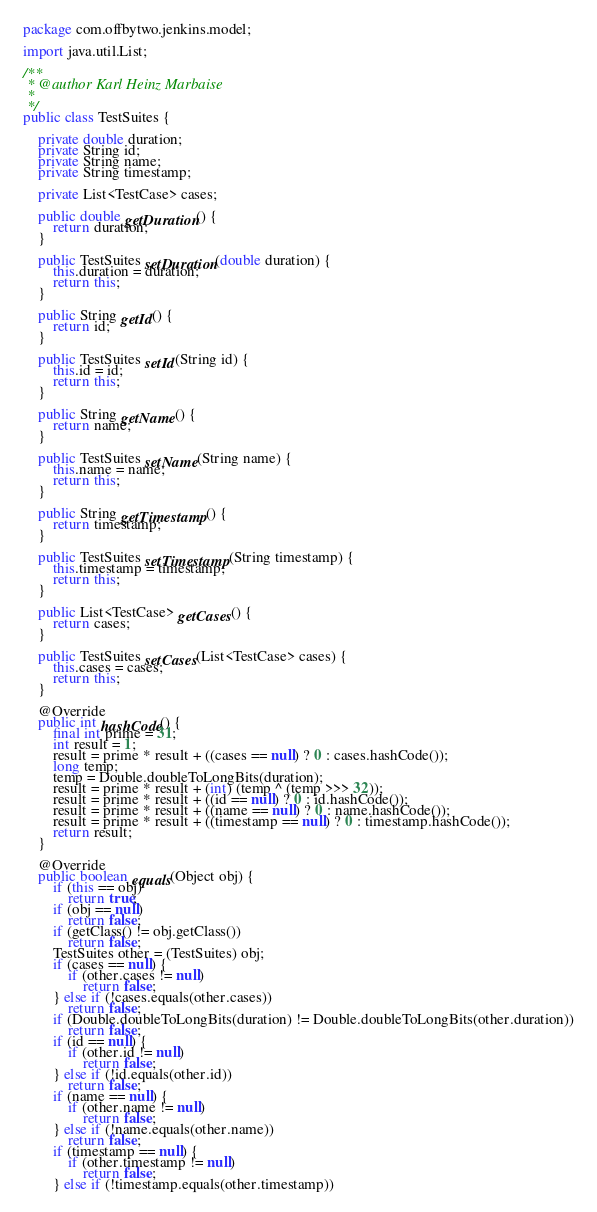Convert code to text. <code><loc_0><loc_0><loc_500><loc_500><_Java_>package com.offbytwo.jenkins.model;

import java.util.List;

/**
 * @author Karl Heinz Marbaise
 *
 */
public class TestSuites {

    private double duration;
    private String id;
    private String name;
    private String timestamp;

    private List<TestCase> cases;

    public double getDuration() {
        return duration;
    }

    public TestSuites setDuration(double duration) {
        this.duration = duration;
        return this;
    }

    public String getId() {
        return id;
    }

    public TestSuites setId(String id) {
        this.id = id;
        return this;
    }

    public String getName() {
        return name;
    }

    public TestSuites setName(String name) {
        this.name = name;
        return this;
    }

    public String getTimestamp() {
        return timestamp;
    }

    public TestSuites setTimestamp(String timestamp) {
        this.timestamp = timestamp;
        return this;
    }

    public List<TestCase> getCases() {
        return cases;
    }

    public TestSuites setCases(List<TestCase> cases) {
        this.cases = cases;
        return this;
    }

    @Override
    public int hashCode() {
        final int prime = 31;
        int result = 1;
        result = prime * result + ((cases == null) ? 0 : cases.hashCode());
        long temp;
        temp = Double.doubleToLongBits(duration);
        result = prime * result + (int) (temp ^ (temp >>> 32));
        result = prime * result + ((id == null) ? 0 : id.hashCode());
        result = prime * result + ((name == null) ? 0 : name.hashCode());
        result = prime * result + ((timestamp == null) ? 0 : timestamp.hashCode());
        return result;
    }

    @Override
    public boolean equals(Object obj) {
        if (this == obj)
            return true;
        if (obj == null)
            return false;
        if (getClass() != obj.getClass())
            return false;
        TestSuites other = (TestSuites) obj;
        if (cases == null) {
            if (other.cases != null)
                return false;
        } else if (!cases.equals(other.cases))
            return false;
        if (Double.doubleToLongBits(duration) != Double.doubleToLongBits(other.duration))
            return false;
        if (id == null) {
            if (other.id != null)
                return false;
        } else if (!id.equals(other.id))
            return false;
        if (name == null) {
            if (other.name != null)
                return false;
        } else if (!name.equals(other.name))
            return false;
        if (timestamp == null) {
            if (other.timestamp != null)
                return false;
        } else if (!timestamp.equals(other.timestamp))</code> 